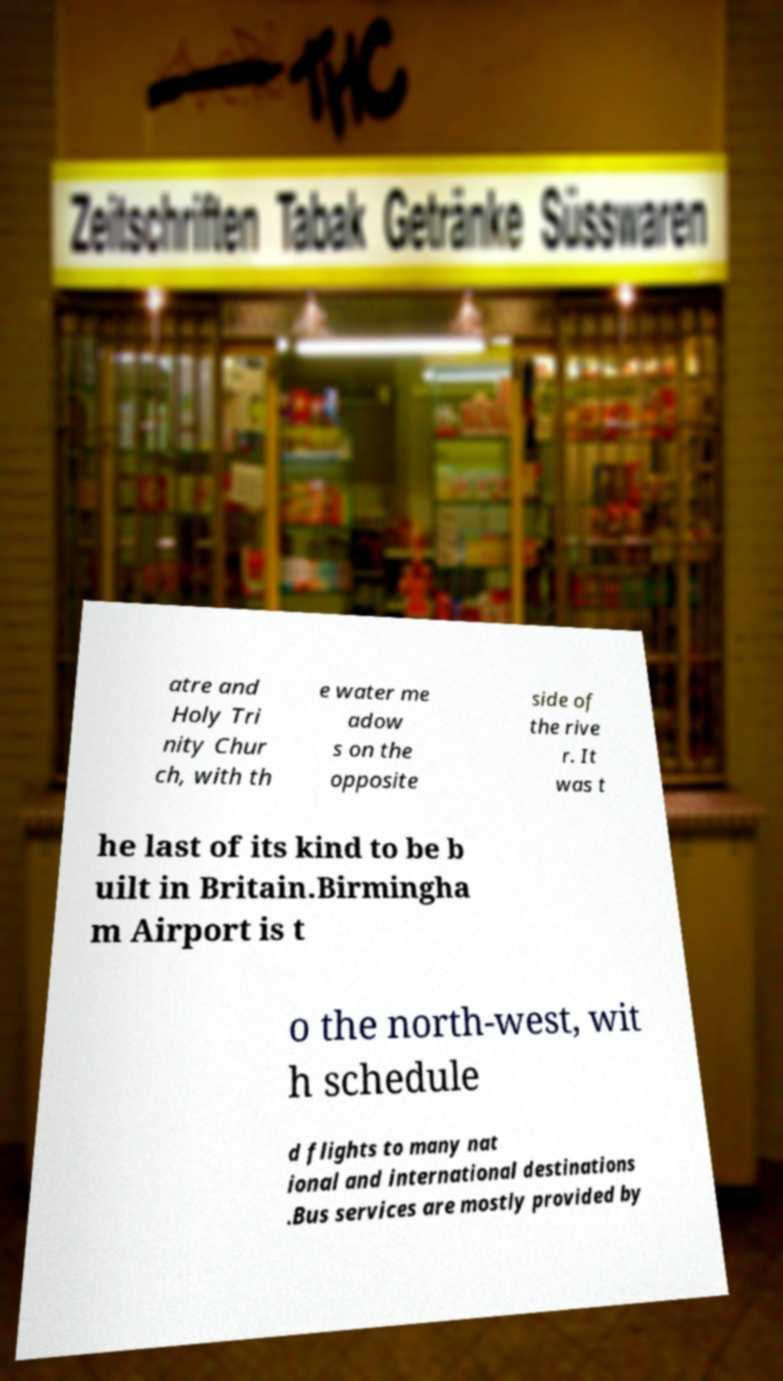There's text embedded in this image that I need extracted. Can you transcribe it verbatim? atre and Holy Tri nity Chur ch, with th e water me adow s on the opposite side of the rive r. It was t he last of its kind to be b uilt in Britain.Birmingha m Airport is t o the north-west, wit h schedule d flights to many nat ional and international destinations .Bus services are mostly provided by 